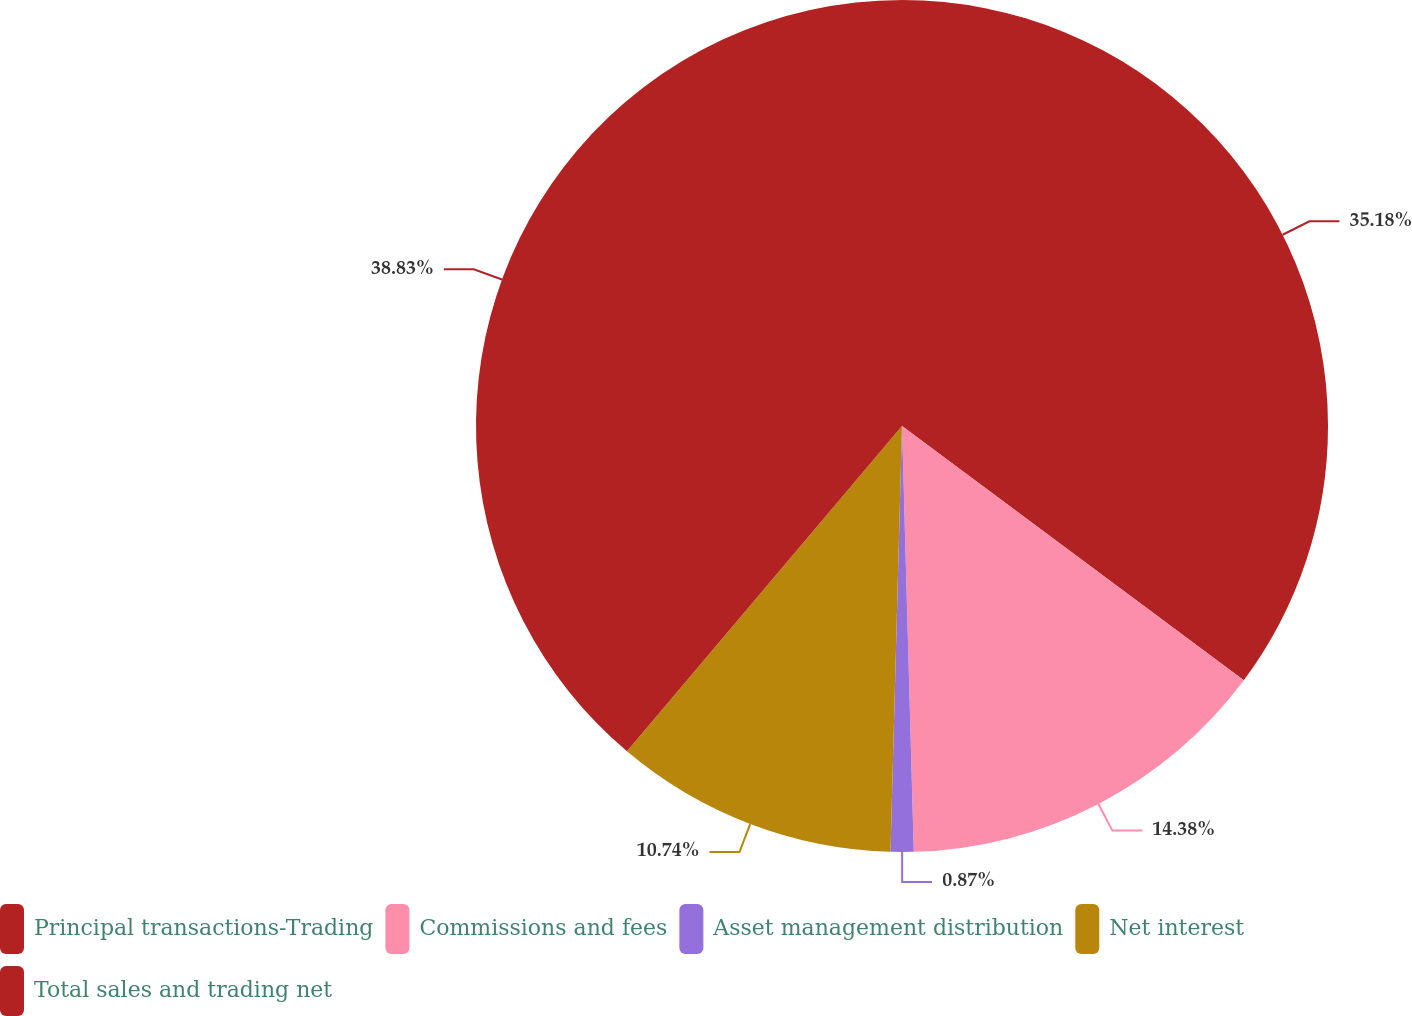<chart> <loc_0><loc_0><loc_500><loc_500><pie_chart><fcel>Principal transactions-Trading<fcel>Commissions and fees<fcel>Asset management distribution<fcel>Net interest<fcel>Total sales and trading net<nl><fcel>35.18%<fcel>14.38%<fcel>0.87%<fcel>10.74%<fcel>38.83%<nl></chart> 